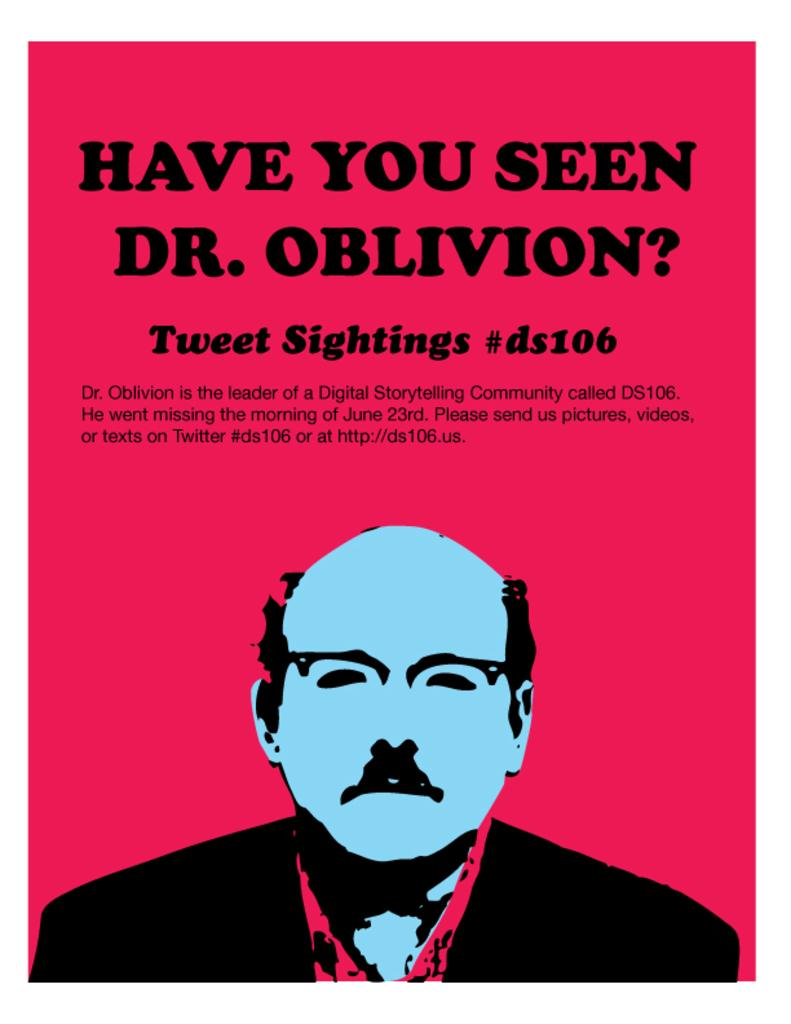<image>
Share a concise interpretation of the image provided. Poster showing a man on the bottom and the phrase "Have you seen Dr.Oblivion" on top. 